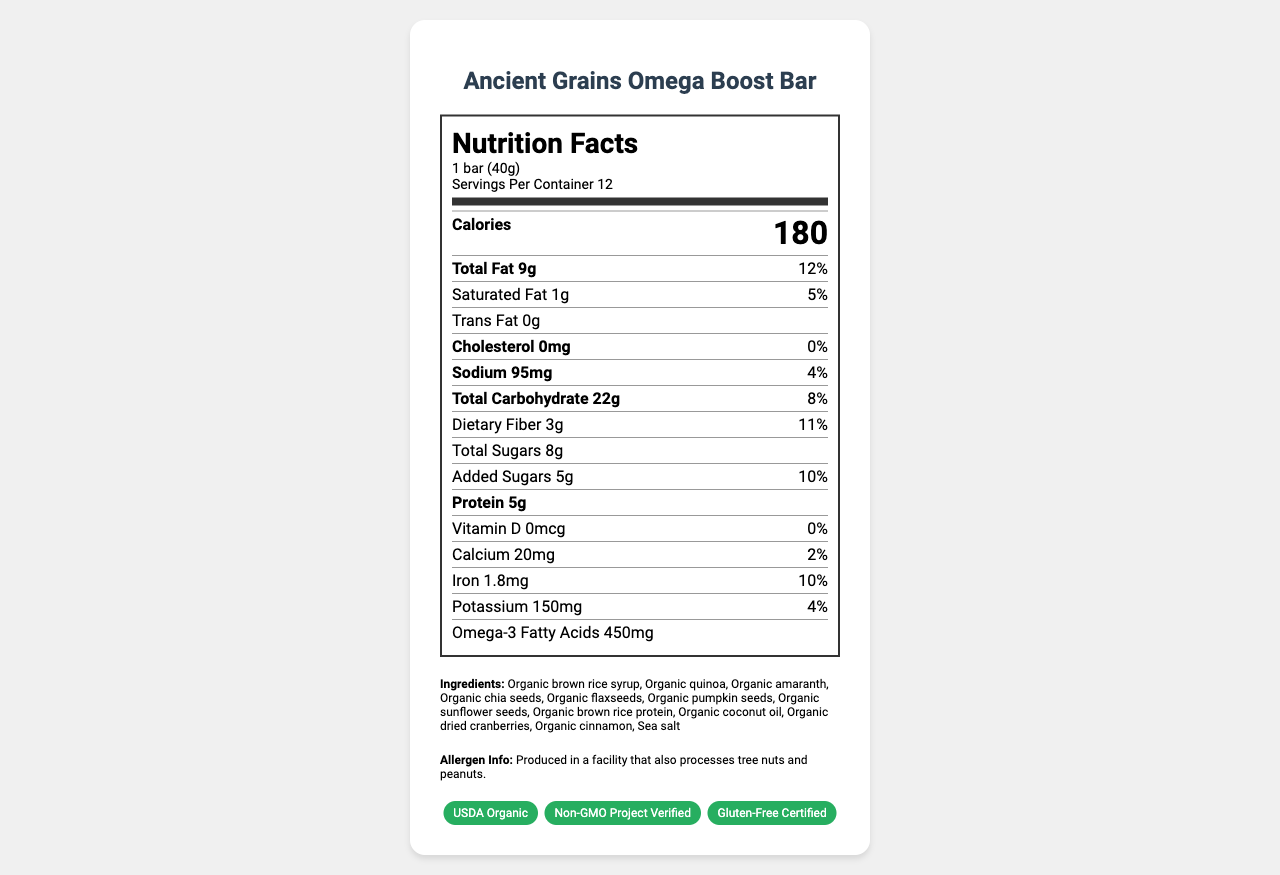what is the serving size for Ancient Grains Omega Boost Bar? The serving size is specified at the top of the nutrition facts section.
Answer: 1 bar (40g) how many calories are there per serving? The calories per serving are prominently displayed in the calories section.
Answer: 180 what is the amount of total fat per serving? The total fat amount is listed in the nutrient row for Total Fat.
Answer: 9g what percentage of the daily value is provided by the saturated fat content? The daily value percentage for saturated fat is stated beside the amount.
Answer: 5% how much sodium is in one serving of the snack bar? The sodium content per serving is listed in its respective nutrient row.
Answer: 95mg what amount of protein does one bar contain? The protein content per serving is displayed in the nutrient section.
Answer: 5g how much calcium is provided per serving and what percentage of the daily value does it represent? The calcium amount and its daily value percentage are shown in the nutrient section.
Answer: 20mg, 2% which ingredient is listed first in the ingredients list? Ingredients are listed in descending order by weight, and the first ingredient is Organic brown rice syrup.
Answer: Organic brown rice syrup what are the certifications associated with the Ancient Grains Omega Boost Bar? The certifications are shown at the bottom of the document in the certifications section.
Answer: USDA Organic, Non-GMO Project Verified, Gluten-Free Certified does this product contain any allergen information? The allergen information specifies that the product is produced in a facility that also processes tree nuts and peanuts.
Answer: Yes how much added sugars are in the snack bar, and what percentage of daily value does it represent? The amount of added sugars and its corresponding daily value percentage are listed together in their nutrient section.
Answer: 5g, 10% which nutrient has the highest daily value percentage per serving? At 12%, total fat has the highest daily value percentage per serving in the document.
Answer: Total Fat which of the following ingredients is not organic? 
A. Flaxseeds
B. Coconut oil
C. Sea salt
D. Quinoa All the listed ingredients except sea salt have the "Organic" label.
Answer: C how many servings are there per container? 
I. 8
II. 10
III. 12 The servings per container are specified as 12 in the serving info section.
Answer: III what is the percentage of daily value for iron content provided by one bar? The daily value percentage for iron is shown next to the iron amount in the nutrient section.
Answer: 10% is this snack bar free of cholesterol? The cholesterol amount is 0mg with a 0% daily value.
Answer: Yes summarize the main idea of the document. This summary captures the essence of the document, focusing on critical nutritional data, key selling points, and additional details such as certifications and allergen information.
Answer: The document provides detailed nutrition information for the Ancient Grains Omega Boost Bar, listing serving size, calories, and nutrient content per serving. It highlights that the snack bar contains ancient grains, omega-3 fatty acids, and is certified organic, non-GMO, and gluten-free. Additionally, it includes an allergen warning and lists the ingredients in descending order by weight. what is the impact of the snack bar's omega-3 fatty acids on health? The document lists the omega-3 fatty acids amount but does not provide information on their health impact.
Answer: Cannot be determined 